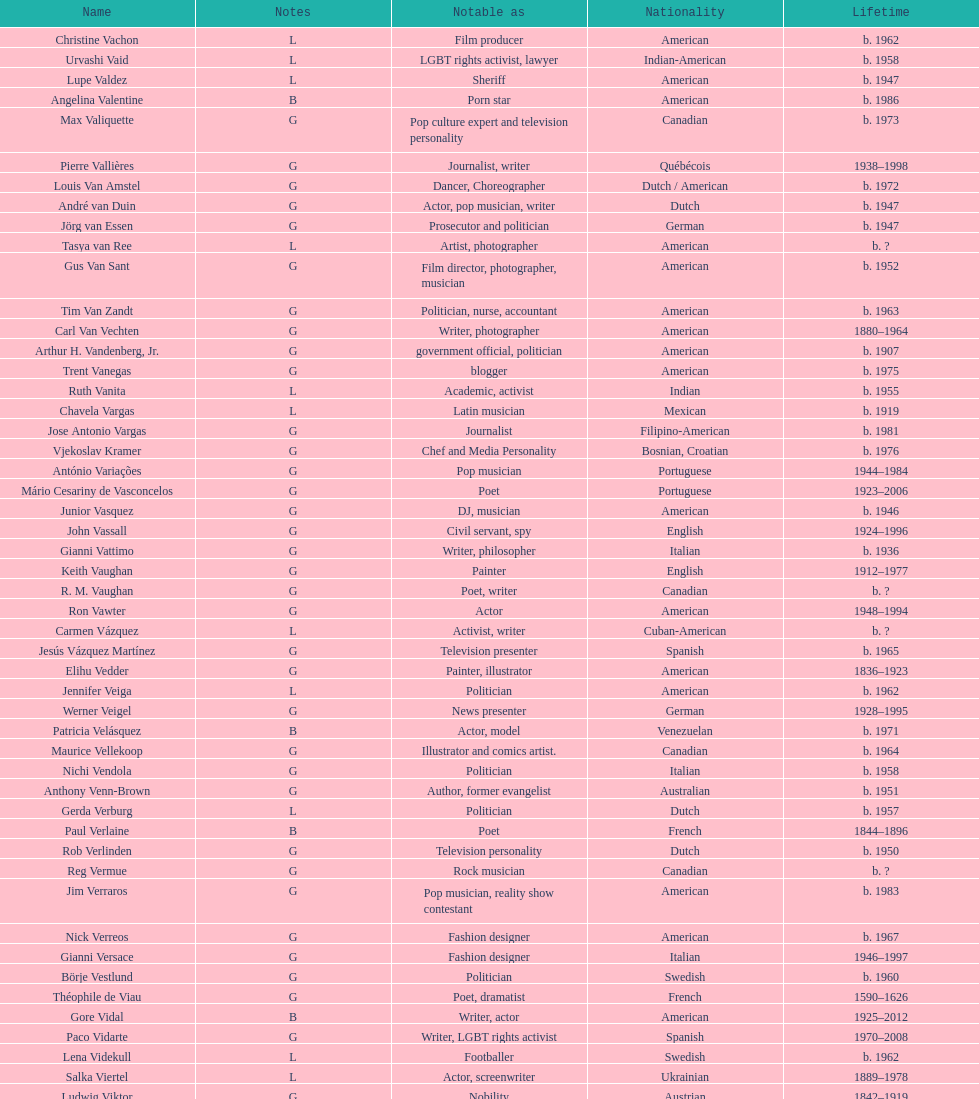Patricia velasquez and ron vawter both had what career? Actor. 